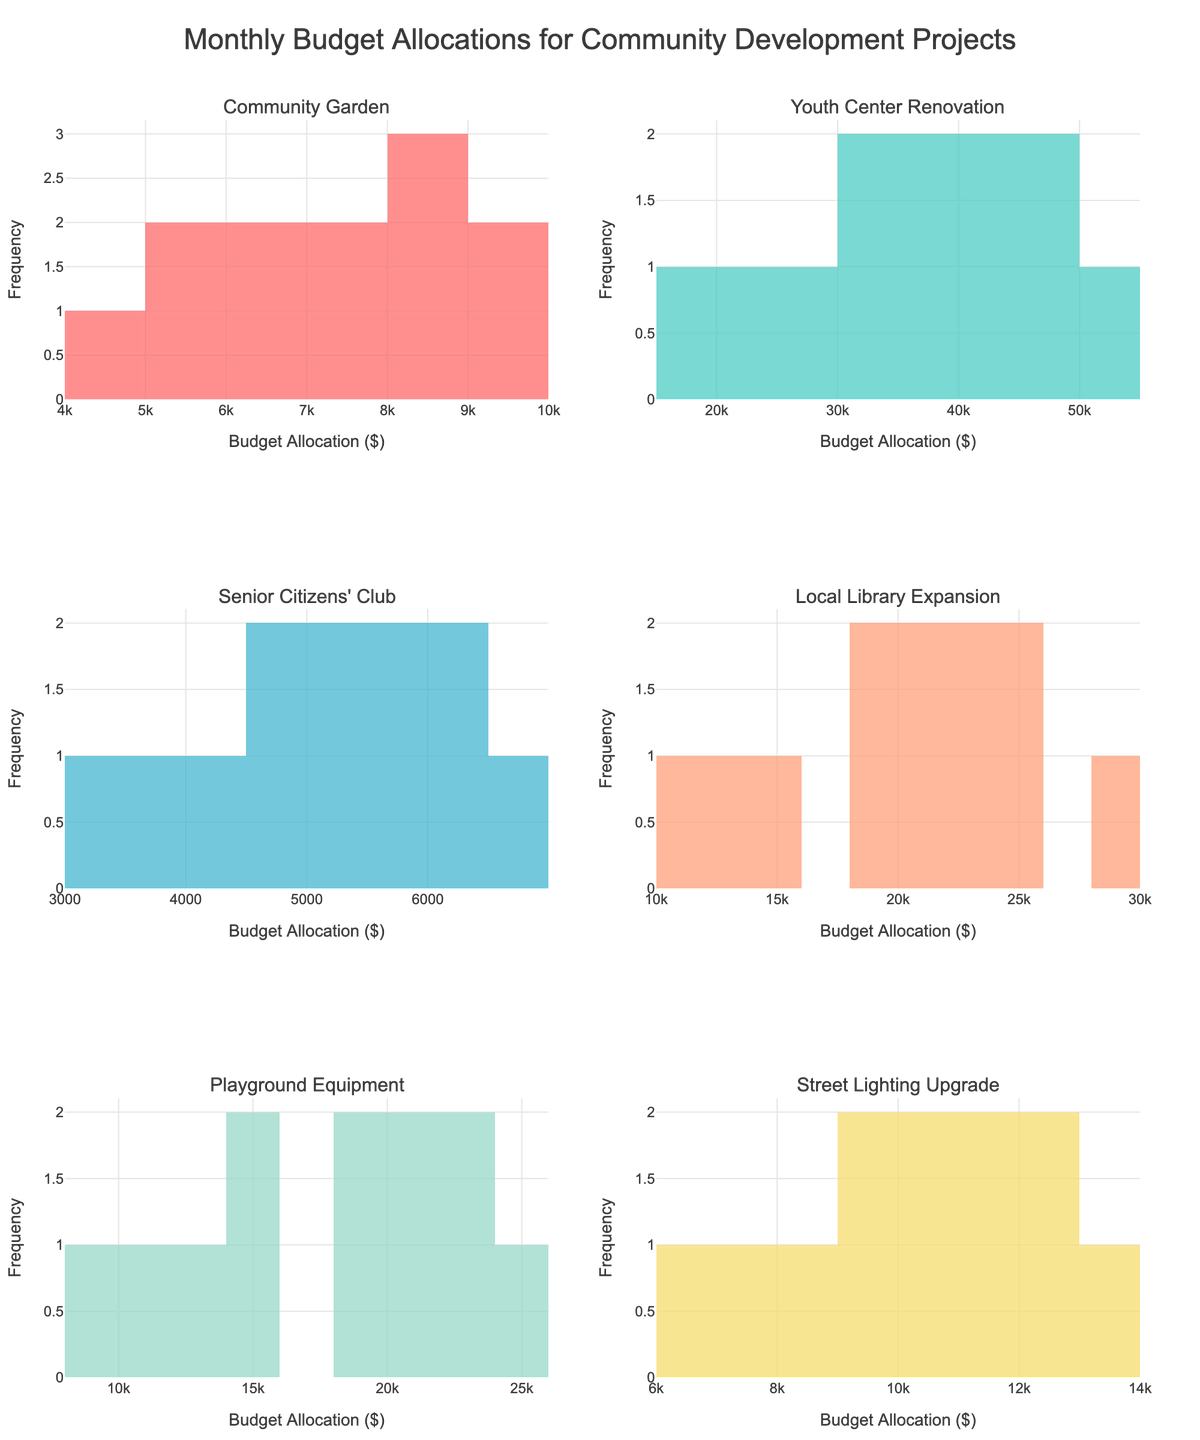What is the title of the figure? The title is prominently displayed at the top of the figure. It reads "Monthly Budget Allocations for Community Development Projects."
Answer: Monthly Budget Allocations for Community Development Projects Which project has the highest budget allocation value? The highest budget allocation is $50,000 under the histogram for the Youth Center Renovation.
Answer: Youth Center Renovation How does the budget allocation for the Local Library Expansion in July compare to that in December? The budget allocation for July is $25,000, while for December it is $18,000. Comparatively, the allocation decreased from July to December.
Answer: It decreased What is the range of budget allocations for the Community Garden project? The minimum allocation for the Community Garden is $4,500, and the maximum is $9,500. Therefore, the range is $9,500 - $4,500 = $5,000.
Answer: $5,000 Which month has the highest frequency of budget allocations across all projects? By visually inspecting all the histograms, the value $20,000 appears most frequently across multiple projects in several months.
Answer: $20,000 How many distinct budget allocations are there for the Senior Citizens' Club project? The histogram for the Senior Citizens' Club project shows distinct bars. Counting the different bars, there are 10 distinct allocations.
Answer: 10 Which project has the smallest range of budget allocations? By comparing the histograms, the Senior Citizens' Club project has the smallest range from $3,000 to $6,500. The range is $6,500 - $3,000 = $3,500.
Answer: Senior Citizens' Club For which project does the budget allocation exhibit a consistent upward trend over the year? By looking at the histograms, the Youth Center Renovation project continuously increases every month, reflecting a consistent upward trend.
Answer: Youth Center Renovation How does the frequency distribution of the Playground Equipment budget allocations differ from that of the Street Lighting Upgrade? The Playground Equipment project has a wider range and higher values ($8,000 to $25,000) compared to the Street Lighting Upgrade, which has lower values ($6,000 to $13,000) and a narrower distribution.
Answer: Playground Equipment has a wider range What percentage of the time does the Local Library Expansion receive a budget allocation greater than $15,000? The Local Library Expansion has 12 months of allocation, out of which more than $15,000 is allocated in 7 months (July, August, September, October, November, December). So, 7/12 * 100 = ~58.33%.
Answer: ~58.33% 